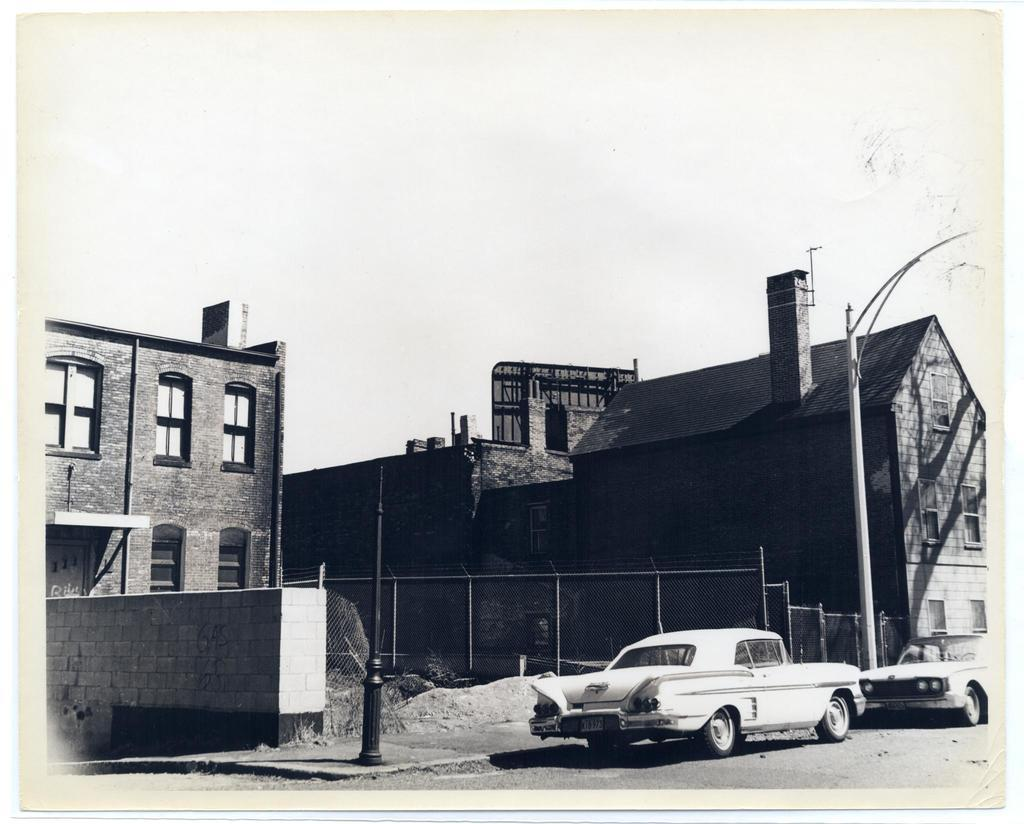What type of photo is in the image? The image contains a black and white photo. What can be seen in the photo? There are buildings, a light pole, a black color pole, a wall, and a fence in the photo. Are there any vehicles in the photo? Yes, there are two cars on the road in the photo. Can you tell me how many people are in the group lifting the screw in the photo? There is no group lifting a screw in the photo; it only contains a black and white photo of various objects and structures. 